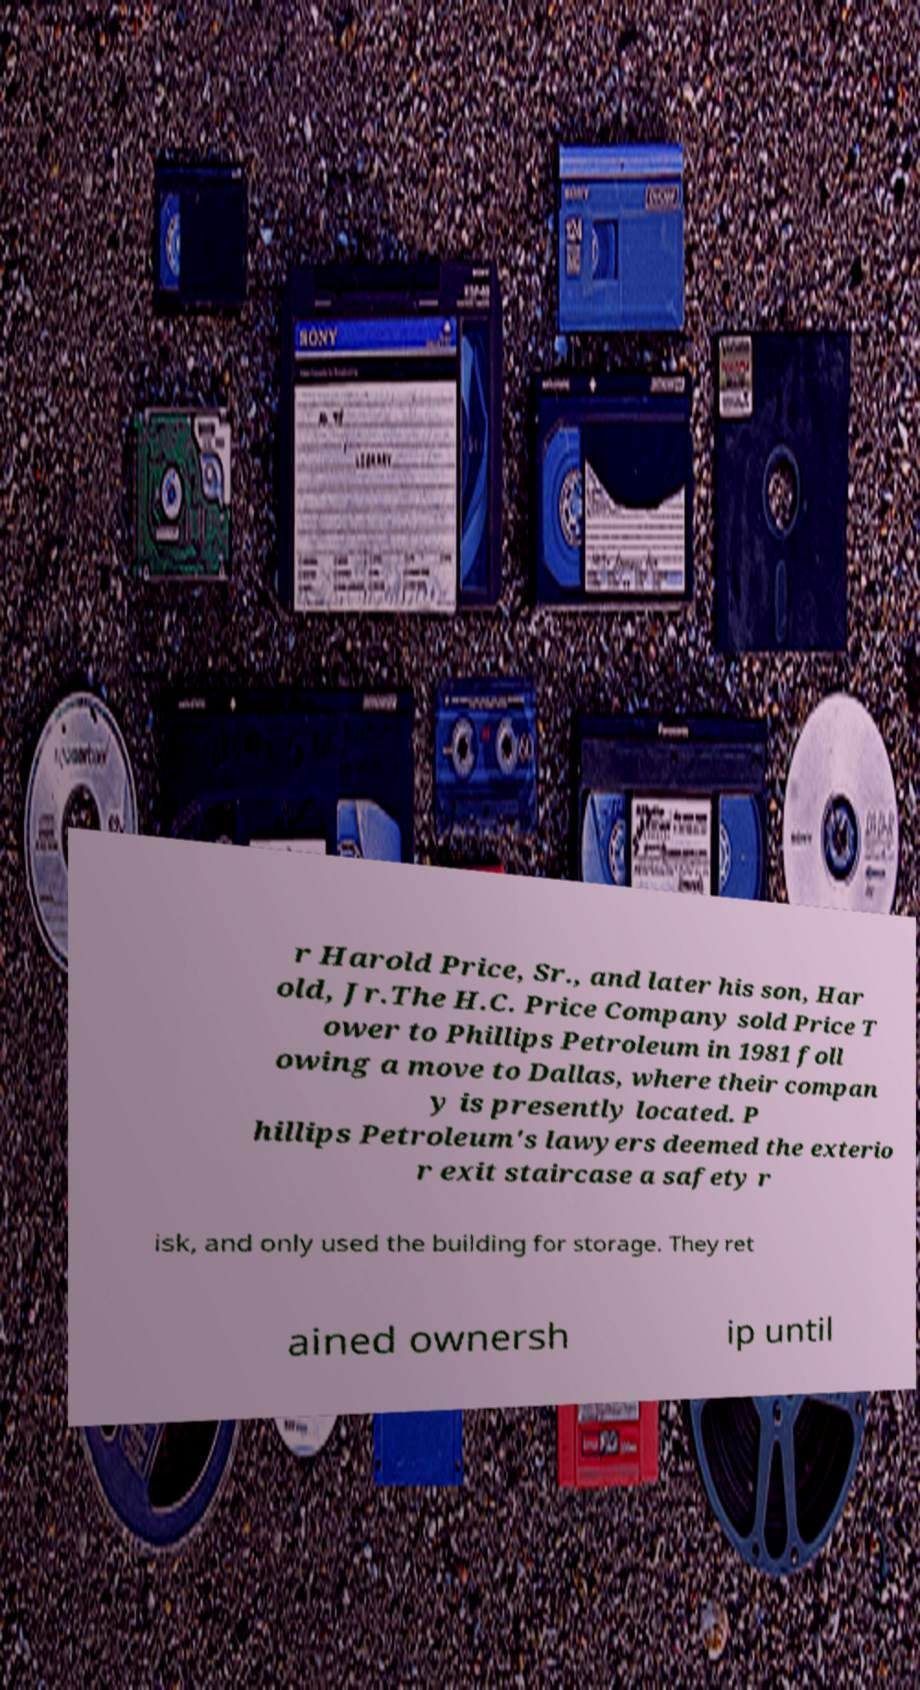Can you read and provide the text displayed in the image?This photo seems to have some interesting text. Can you extract and type it out for me? r Harold Price, Sr., and later his son, Har old, Jr.The H.C. Price Company sold Price T ower to Phillips Petroleum in 1981 foll owing a move to Dallas, where their compan y is presently located. P hillips Petroleum's lawyers deemed the exterio r exit staircase a safety r isk, and only used the building for storage. They ret ained ownersh ip until 